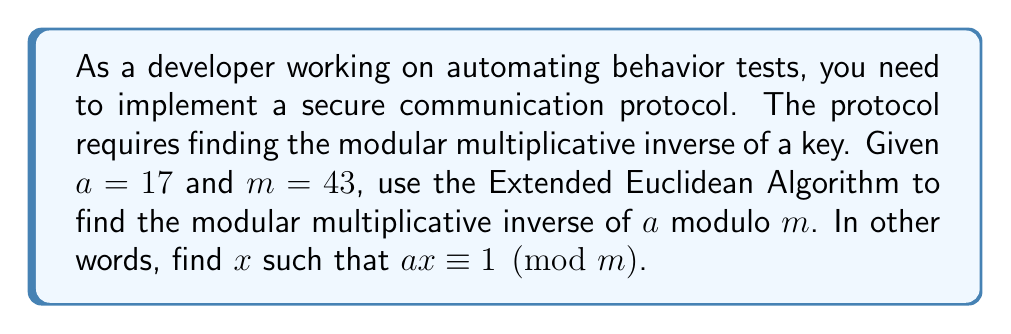Show me your answer to this math problem. To find the modular multiplicative inverse using the Extended Euclidean Algorithm, we follow these steps:

1) Initialize variables:
   $r_0 = m = 43$, $r_1 = a = 17$
   $s_0 = 1$, $s_1 = 0$
   $t_0 = 0$, $t_1 = 1$

2) Apply the algorithm:

   $43 = 2 \times 17 + 9$
   $r_2 = 9$, $s_2 = 1 - 2 \times 0 = 1$, $t_2 = 0 - 2 \times 1 = -2$

   $17 = 1 \times 9 + 8$
   $r_3 = 8$, $s_3 = 0 - 1 \times 1 = -1$, $t_3 = 1 - 1 \times (-2) = 3$

   $9 = 1 \times 8 + 1$
   $r_4 = 1$, $s_4 = 1 - 1 \times (-1) = 2$, $t_4 = -2 - 1 \times 3 = -5$

   $8 = 8 \times 1 + 0$

3) The algorithm stops when we reach a remainder of 0. The last non-zero remainder is 1, which means gcd(17, 43) = 1, so the modular inverse exists.

4) The coefficients in the last row where the remainder is 1 give us the Bézout's identity:
   $1 = 2 \times 43 + (-5) \times 17$

5) The modular multiplicative inverse of 17 modulo 43 is -5, or 38 when reduced modulo 43 (since -5 ≡ 38 (mod 43)).

We can verify: $17 \times 38 = 646 \equiv 1 \pmod{43}$
Answer: The modular multiplicative inverse of 17 modulo 43 is 38. 